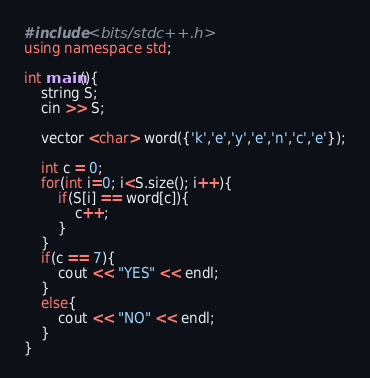Convert code to text. <code><loc_0><loc_0><loc_500><loc_500><_C++_>#include <bits/stdc++.h>
using namespace std;

int main(){
    string S;
    cin >> S;
    
    vector <char> word({'k','e','y','e','n','c','e'});

    int c = 0;
    for(int i=0; i<S.size(); i++){
        if(S[i] == word[c]){
            c++;
        }
    }
    if(c == 7){
        cout << "YES" << endl;
    }
    else{
        cout << "NO" << endl;
    }
}</code> 